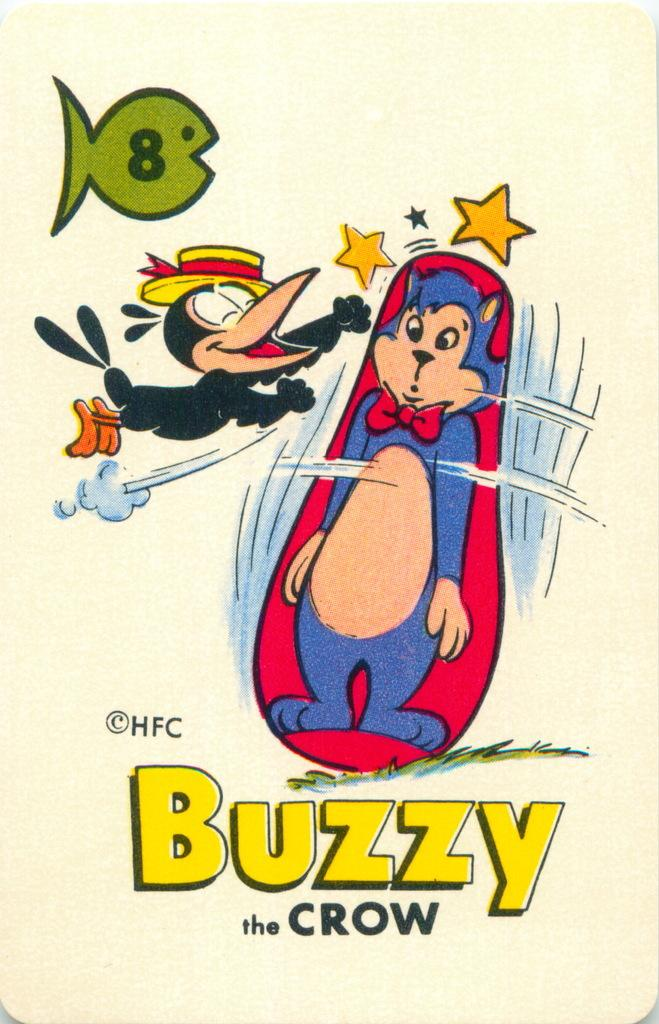<image>
Present a compact description of the photo's key features. A cartoon poster that says Buzzy the Crow. 